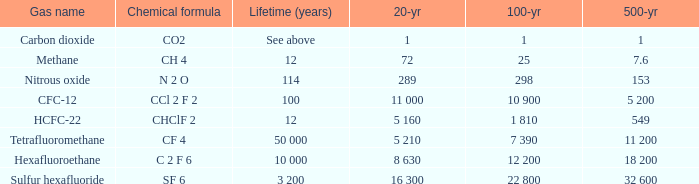What is the 20 year for Nitrous Oxide? 289.0. 